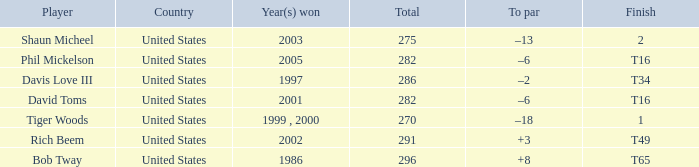In which year(s) did the person with a total greater than 286 win? 2002, 1986. 